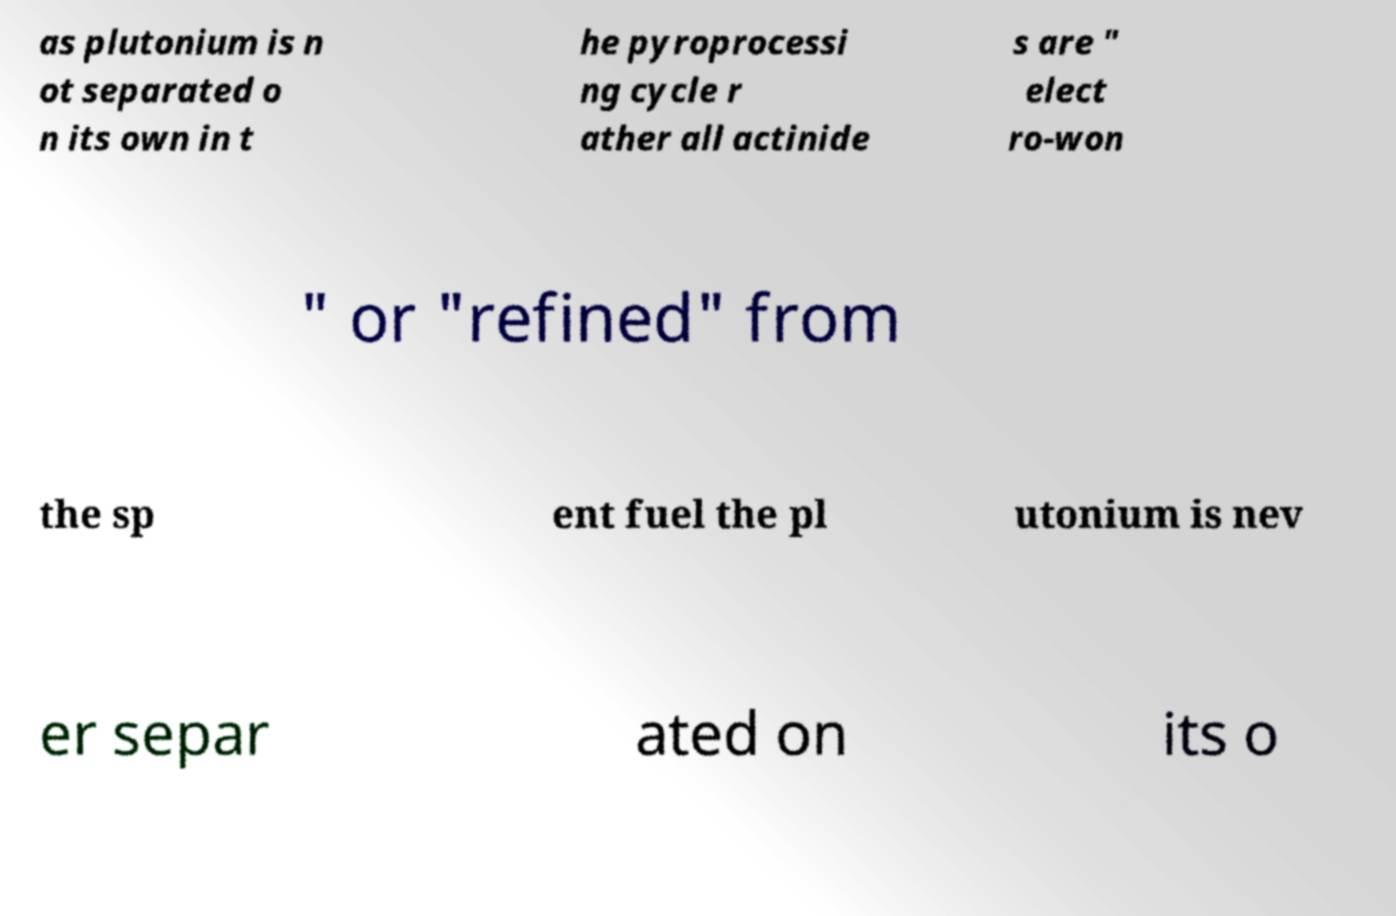Can you read and provide the text displayed in the image?This photo seems to have some interesting text. Can you extract and type it out for me? as plutonium is n ot separated o n its own in t he pyroprocessi ng cycle r ather all actinide s are " elect ro-won " or "refined" from the sp ent fuel the pl utonium is nev er separ ated on its o 